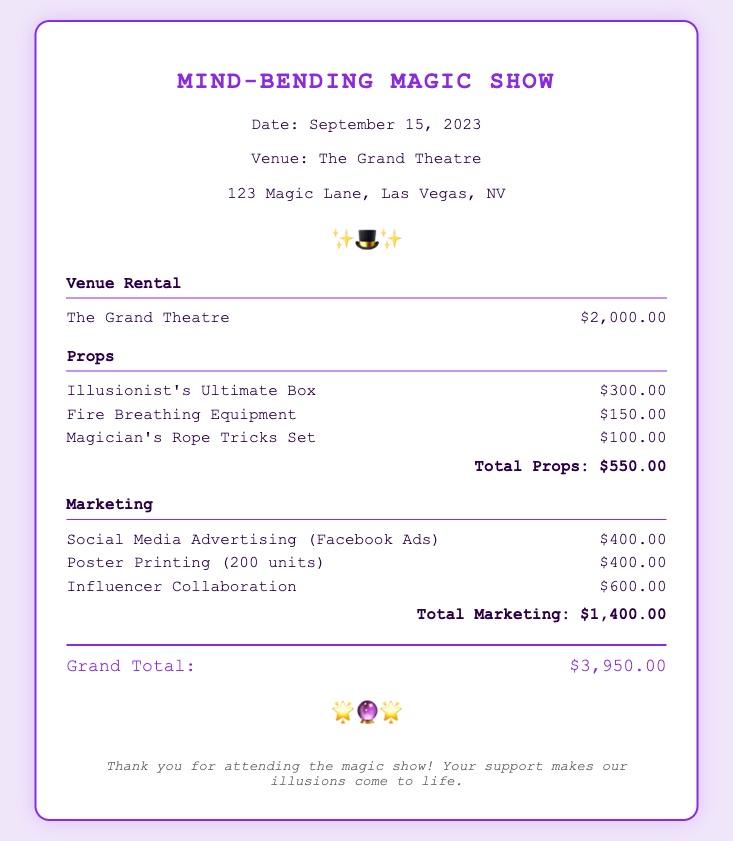What is the date of the magic show? The date of the magic show is specified in the document as September 15, 2023.
Answer: September 15, 2023 What is the venue name? The venue name for the magic show is mentioned as The Grand Theatre.
Answer: The Grand Theatre How much did the venue rental cost? The cost of venue rental is provided as $2,000.00.
Answer: $2,000.00 What is the total cost of the props? The total cost of the props is calculated and stated as $550.00.
Answer: $550.00 What was the cost of social media advertising? The document specifies the cost of social media advertising as $400.00.
Answer: $400.00 What is the grand total of expenses? The grand total of expenses is listed as $3,950.00, which is the sum of all itemized expenses.
Answer: $3,950.00 How many units of posters were printed? The document indicates that 200 units of posters were printed.
Answer: 200 units Which expense category had the highest cost? Among the categories listed, Marketing had the highest total cost of $1,400.00.
Answer: Marketing What decorative symbols are used in the document? The document includes the decorative symbols "✨🎩✨" and "🌟🔮🌟".
Answer: ✨🎩✨ and 🌟🔮🌟 